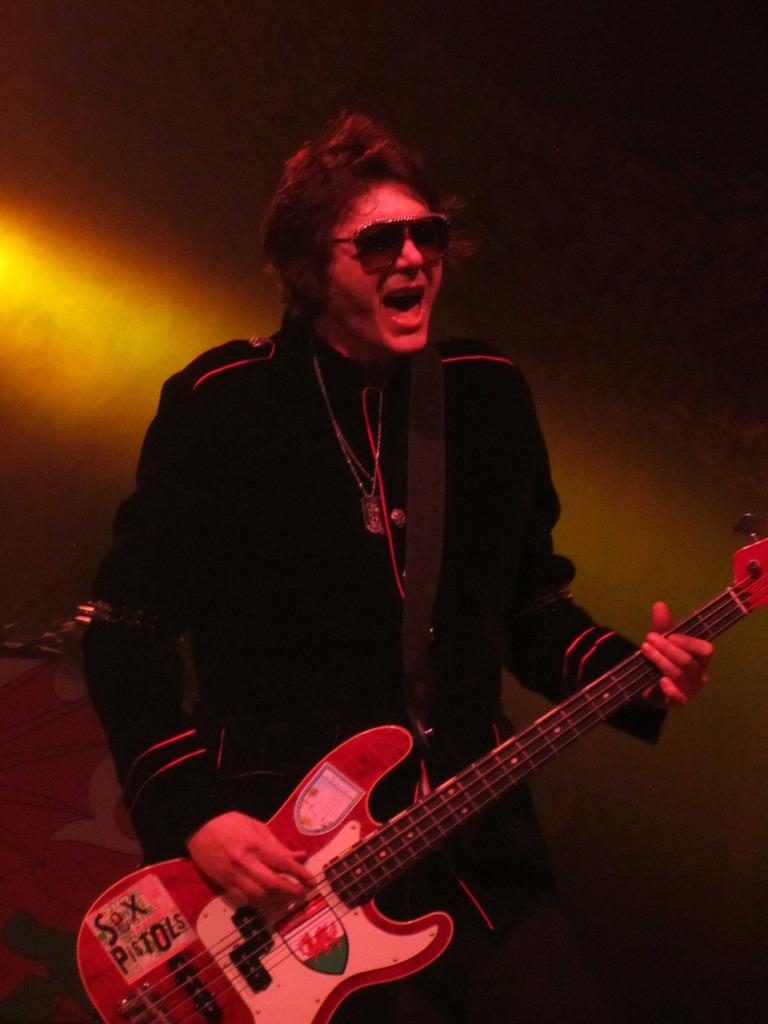What is the person in the image doing with their hands? The person is holding a guitar. What activity is the person engaged in? The person is singing. What type of accessory is the person wearing on their face? The person is wearing goggles. What color is the shirt the person is wearing? The person is wearing a black shirt. What type of wing can be seen on the person in the image? There is no wing present on the person in the image. Is the person celebrating a birthday in the image? There is no indication of a birthday celebration in the image. 